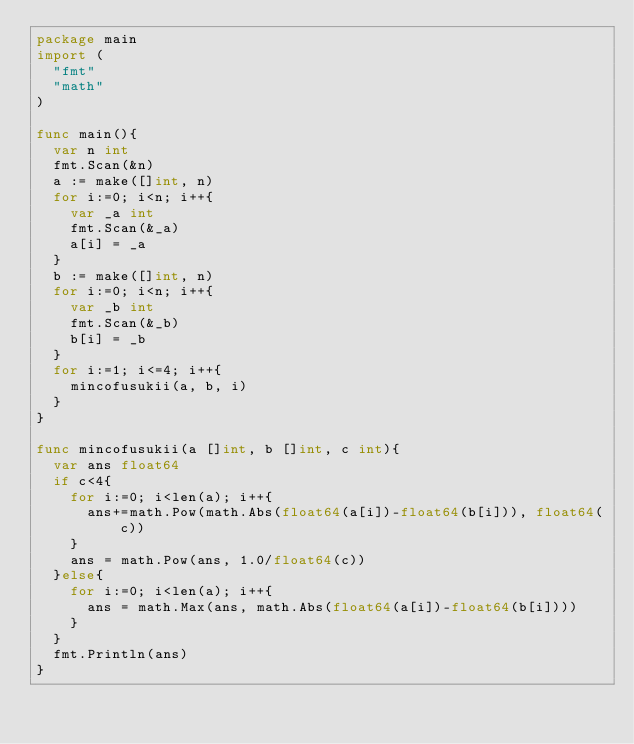<code> <loc_0><loc_0><loc_500><loc_500><_Go_>package main
import (
	"fmt"
	"math"
)

func main(){
	var n int
	fmt.Scan(&n)
	a := make([]int, n)
	for i:=0; i<n; i++{
		var _a int
		fmt.Scan(&_a)
		a[i] = _a
	}
	b := make([]int, n)
	for i:=0; i<n; i++{
		var _b int
		fmt.Scan(&_b)
		b[i] = _b
	}
	for i:=1; i<=4; i++{
		mincofusukii(a, b, i)
	}
}

func mincofusukii(a []int, b []int, c int){
	var ans float64
	if c<4{
		for i:=0; i<len(a); i++{
			ans+=math.Pow(math.Abs(float64(a[i])-float64(b[i])), float64(c))
		}
		ans = math.Pow(ans, 1.0/float64(c))
	}else{
		for i:=0; i<len(a); i++{
			ans = math.Max(ans, math.Abs(float64(a[i])-float64(b[i])))
		}
	}
	fmt.Println(ans)
}
</code> 